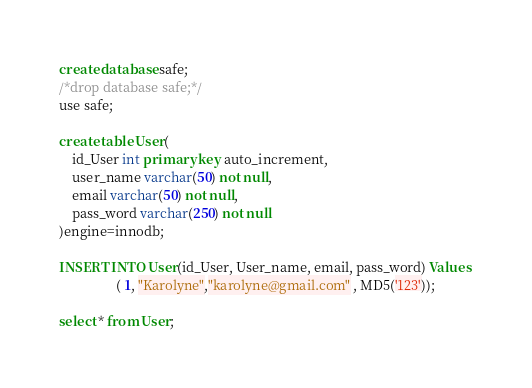Convert code to text. <code><loc_0><loc_0><loc_500><loc_500><_SQL_>create database safe;
/*drop database safe;*/
use safe;

create table User( 
	id_User int primary key auto_increment, 
    user_name varchar(50) not null,
	email varchar(50) not null,
	pass_word varchar(250) not null
)engine=innodb; 	

INSERT INTO User(id_User, User_name, email, pass_word) Values 
				 ( 1, "Karolyne","karolyne@gmail.com" , MD5('123'));

select * from User;</code> 